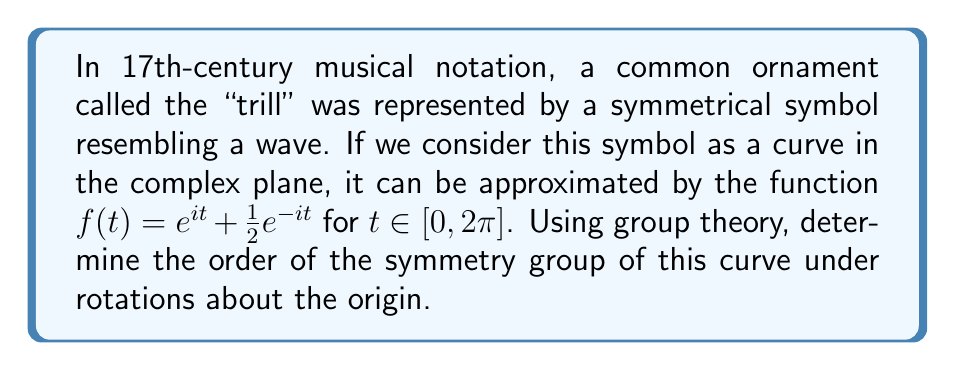Could you help me with this problem? To analyze the symmetry of this curve using group theory, we need to follow these steps:

1) First, let's understand what symmetry means in this context. A rotation symmetry exists if the curve looks the same after being rotated by a certain angle about the origin.

2) The symmetry group of this curve under rotations will be a subgroup of SO(2), the special orthogonal group in two dimensions, which represents all rotations in the plane.

3) To find the symmetries, we need to find all angles $\theta$ such that rotating the curve by $\theta$ leaves it unchanged. Mathematically, this means:

   $f(t+\theta) = f(t)$ for all $t$

4) Expanding this equation:

   $e^{i(t+\theta)} + \frac{1}{2}e^{-i(t+\theta)} = e^{it} + \frac{1}{2}e^{-it}$

5) Using the properties of complex exponentials:

   $e^{it}e^{i\theta} + \frac{1}{2}e^{-it}e^{-i\theta} = e^{it} + \frac{1}{2}e^{-it}$

6) For this to be true for all $t$, we must have:

   $e^{i\theta} = 1$ and $e^{-i\theta} = 1$

7) The solutions to these equations are:

   $\theta = 2\pi n$ for any integer $n$

8) This means the curve has a rotational symmetry of $2\pi$, or 360°. In other words, it has only the trivial rotational symmetry.

9) In group theory terms, the symmetry group of this curve under rotations is isomorphic to the trivial group $\{e\}$, where $e$ represents the identity rotation (no rotation at all).

10) The order of a group is the number of elements in the group. In this case, there is only one element (the identity rotation).
Answer: The order of the symmetry group of the curve under rotations is 1. 